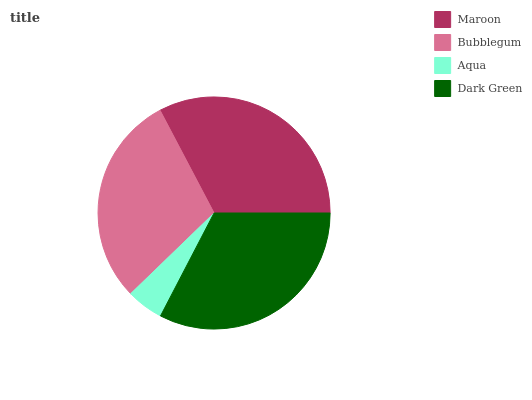Is Aqua the minimum?
Answer yes or no. Yes. Is Maroon the maximum?
Answer yes or no. Yes. Is Bubblegum the minimum?
Answer yes or no. No. Is Bubblegum the maximum?
Answer yes or no. No. Is Maroon greater than Bubblegum?
Answer yes or no. Yes. Is Bubblegum less than Maroon?
Answer yes or no. Yes. Is Bubblegum greater than Maroon?
Answer yes or no. No. Is Maroon less than Bubblegum?
Answer yes or no. No. Is Dark Green the high median?
Answer yes or no. Yes. Is Bubblegum the low median?
Answer yes or no. Yes. Is Bubblegum the high median?
Answer yes or no. No. Is Dark Green the low median?
Answer yes or no. No. 